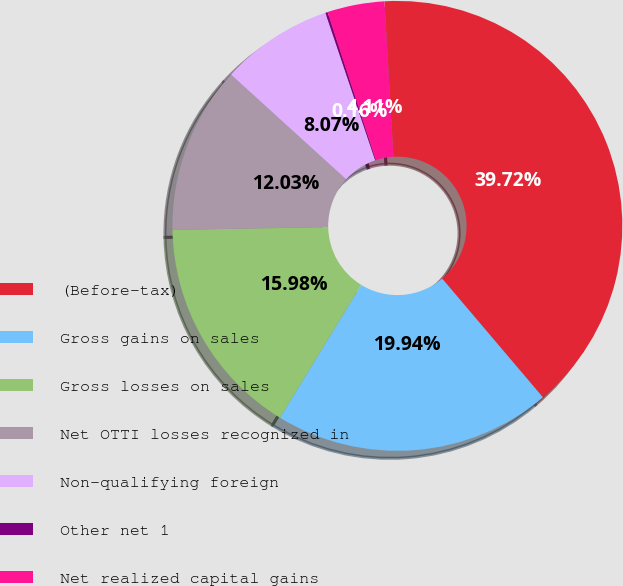Convert chart to OTSL. <chart><loc_0><loc_0><loc_500><loc_500><pie_chart><fcel>(Before-tax)<fcel>Gross gains on sales<fcel>Gross losses on sales<fcel>Net OTTI losses recognized in<fcel>Non-qualifying foreign<fcel>Other net 1<fcel>Net realized capital gains<nl><fcel>39.72%<fcel>19.94%<fcel>15.98%<fcel>12.03%<fcel>8.07%<fcel>0.16%<fcel>4.11%<nl></chart> 